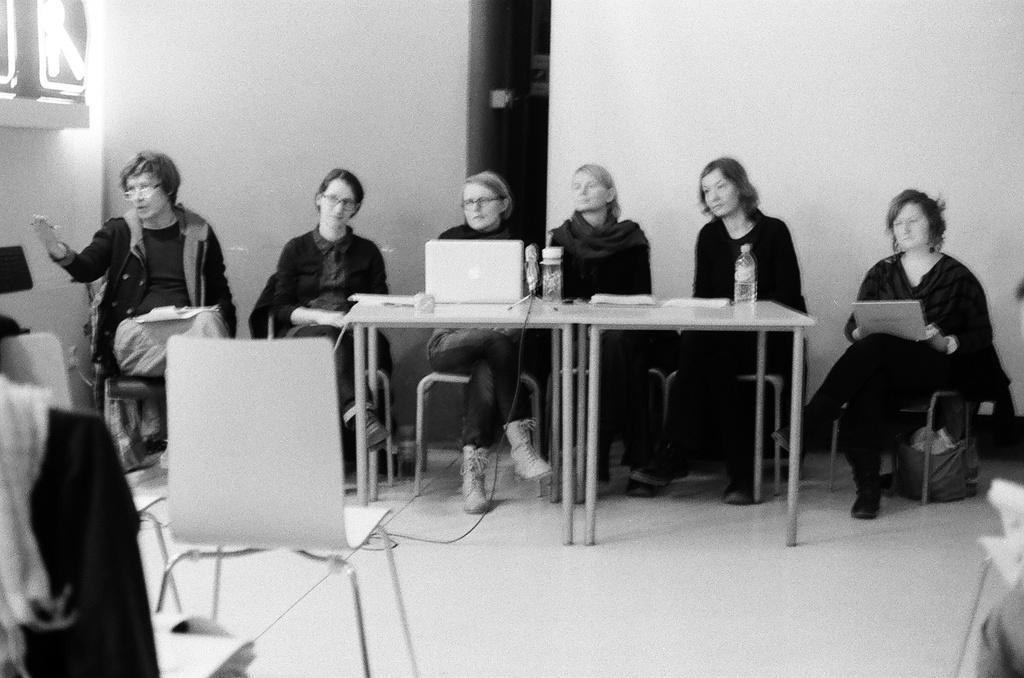Could you give a brief overview of what you see in this image? There are six women sitting in the chair at the table and also there are laptops,water bottles,papers on the table. We can see chairs,wall in the image. 